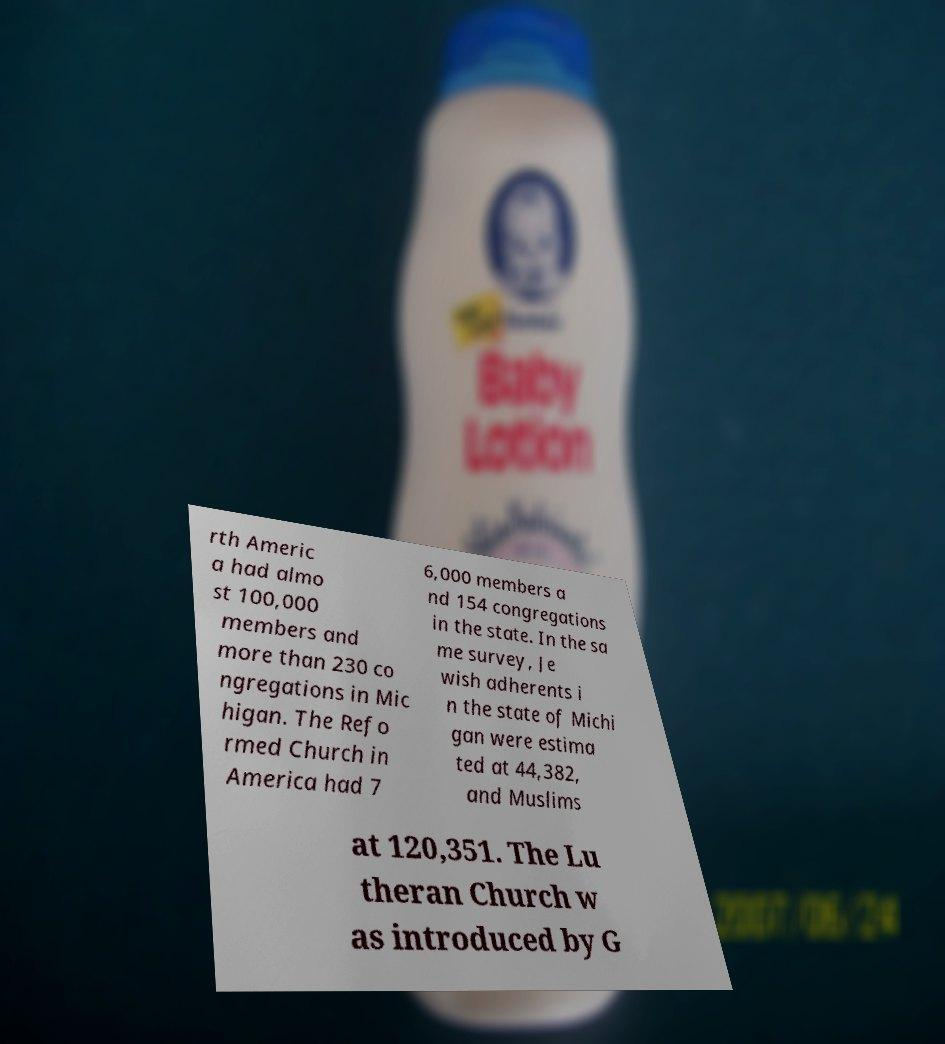Please identify and transcribe the text found in this image. rth Americ a had almo st 100,000 members and more than 230 co ngregations in Mic higan. The Refo rmed Church in America had 7 6,000 members a nd 154 congregations in the state. In the sa me survey, Je wish adherents i n the state of Michi gan were estima ted at 44,382, and Muslims at 120,351. The Lu theran Church w as introduced by G 